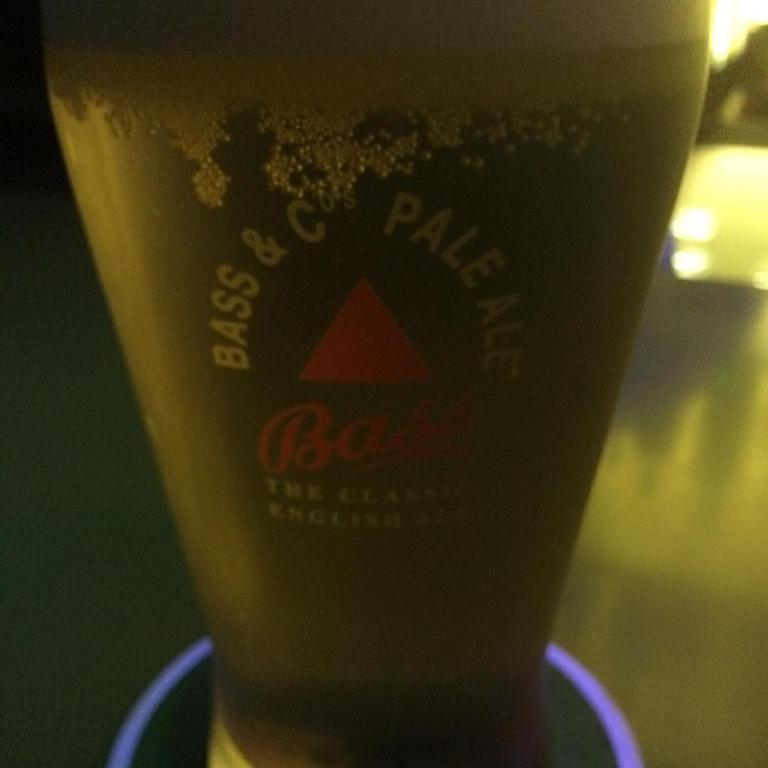What is in the glass that is visible in the image? There is a drink in the glass in the image. Where is the glass placed in the image? The glass is placed on a platform in the image. Can you describe the background of the image? The background of the image is blurry. What type of cars can be seen driving through the cork in the image? There are no cars or cork present in the image; it only features a glass with a drink and a blurry background. 